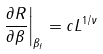<formula> <loc_0><loc_0><loc_500><loc_500>\left . \frac { \partial R } { \partial \beta } \right | _ { \beta _ { f } } = c L ^ { 1 / \nu }</formula> 